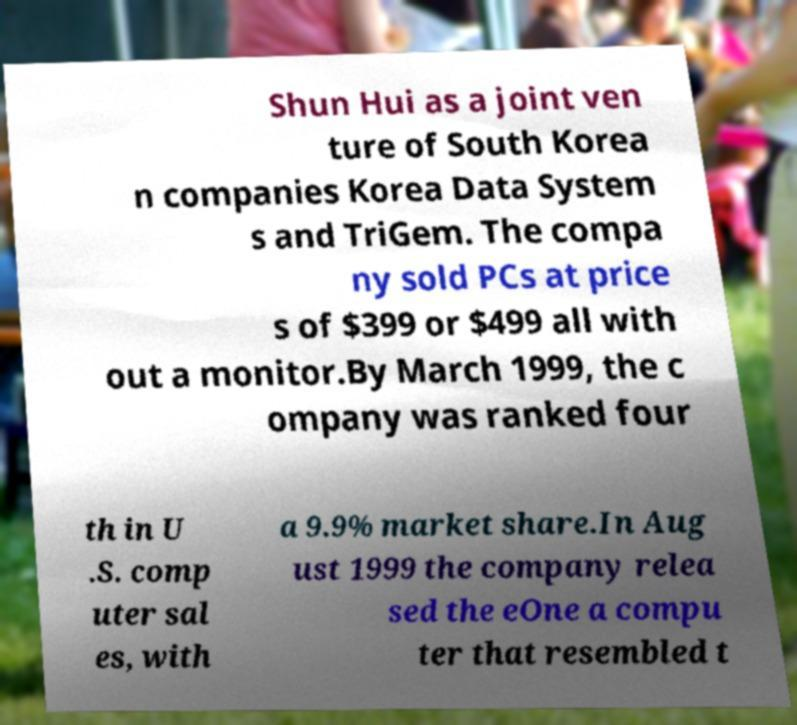What messages or text are displayed in this image? I need them in a readable, typed format. Shun Hui as a joint ven ture of South Korea n companies Korea Data System s and TriGem. The compa ny sold PCs at price s of $399 or $499 all with out a monitor.By March 1999, the c ompany was ranked four th in U .S. comp uter sal es, with a 9.9% market share.In Aug ust 1999 the company relea sed the eOne a compu ter that resembled t 